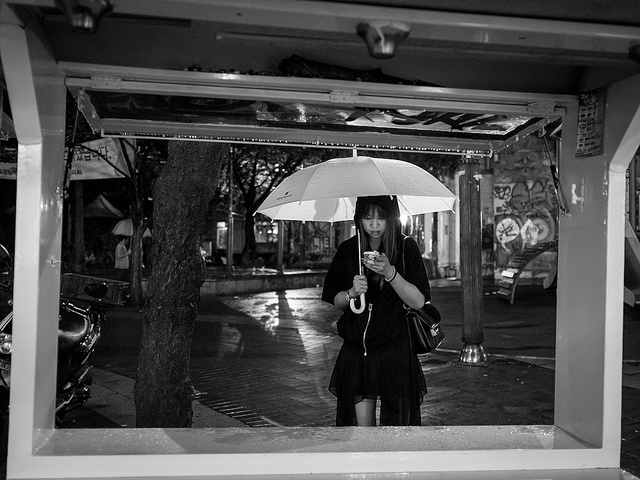Describe the objects in this image and their specific colors. I can see people in black, gray, and lightgray tones, umbrella in black, darkgray, lightgray, and gray tones, motorcycle in black, gray, darkgray, and lightgray tones, handbag in black, gray, darkgray, and lightgray tones, and people in gray and black tones in this image. 